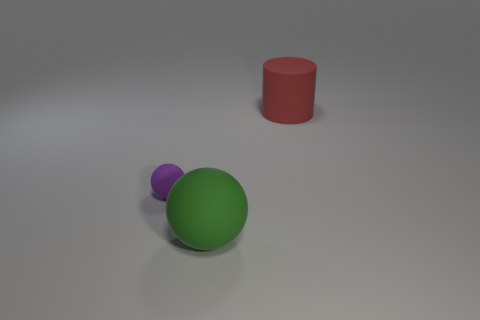There is a small purple sphere; what number of big things are behind it?
Keep it short and to the point. 1. Are there any yellow matte cylinders of the same size as the purple matte thing?
Ensure brevity in your answer.  No. Is the shape of the object that is in front of the tiny purple object the same as  the small matte thing?
Your answer should be compact. Yes. What is the color of the big matte cylinder?
Offer a very short reply. Red. Is there a small purple cylinder?
Offer a very short reply. No. What is the size of the purple ball that is made of the same material as the red cylinder?
Offer a very short reply. Small. What is the shape of the object in front of the matte sphere that is to the left of the big rubber object that is in front of the big rubber cylinder?
Give a very brief answer. Sphere. Is the number of spheres that are in front of the rubber cylinder the same as the number of rubber balls?
Offer a terse response. Yes. Does the small object have the same shape as the big green rubber thing?
Offer a terse response. Yes. What number of objects are rubber balls behind the big rubber ball or rubber things?
Offer a terse response. 3. 